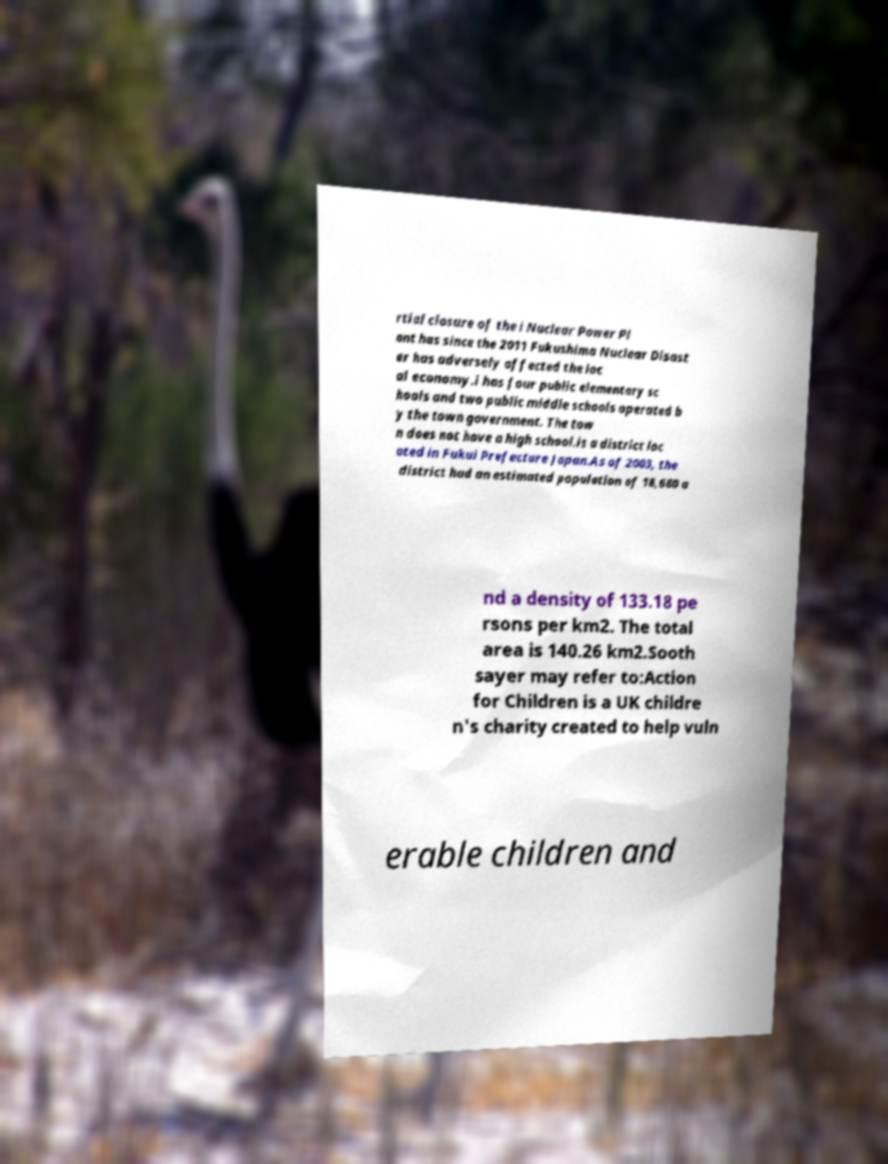Can you read and provide the text displayed in the image?This photo seems to have some interesting text. Can you extract and type it out for me? rtial closure of the i Nuclear Power Pl ant has since the 2011 Fukushima Nuclear Disast er has adversely affected the loc al economy.i has four public elementary sc hools and two public middle schools operated b y the town government. The tow n does not have a high school.is a district loc ated in Fukui Prefecture Japan.As of 2003, the district had an estimated population of 18,680 a nd a density of 133.18 pe rsons per km2. The total area is 140.26 km2.Sooth sayer may refer to:Action for Children is a UK childre n's charity created to help vuln erable children and 